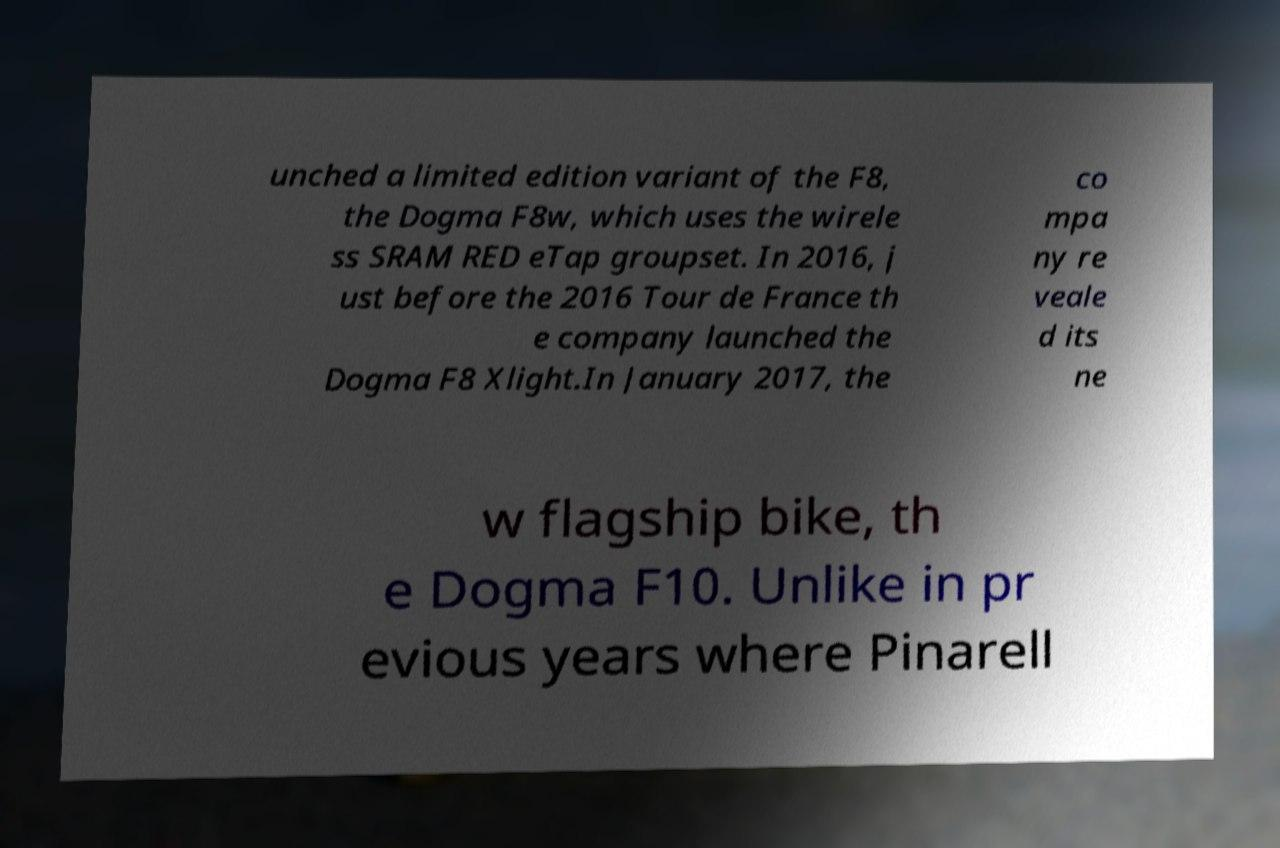Could you assist in decoding the text presented in this image and type it out clearly? unched a limited edition variant of the F8, the Dogma F8w, which uses the wirele ss SRAM RED eTap groupset. In 2016, j ust before the 2016 Tour de France th e company launched the Dogma F8 Xlight.In January 2017, the co mpa ny re veale d its ne w flagship bike, th e Dogma F10. Unlike in pr evious years where Pinarell 